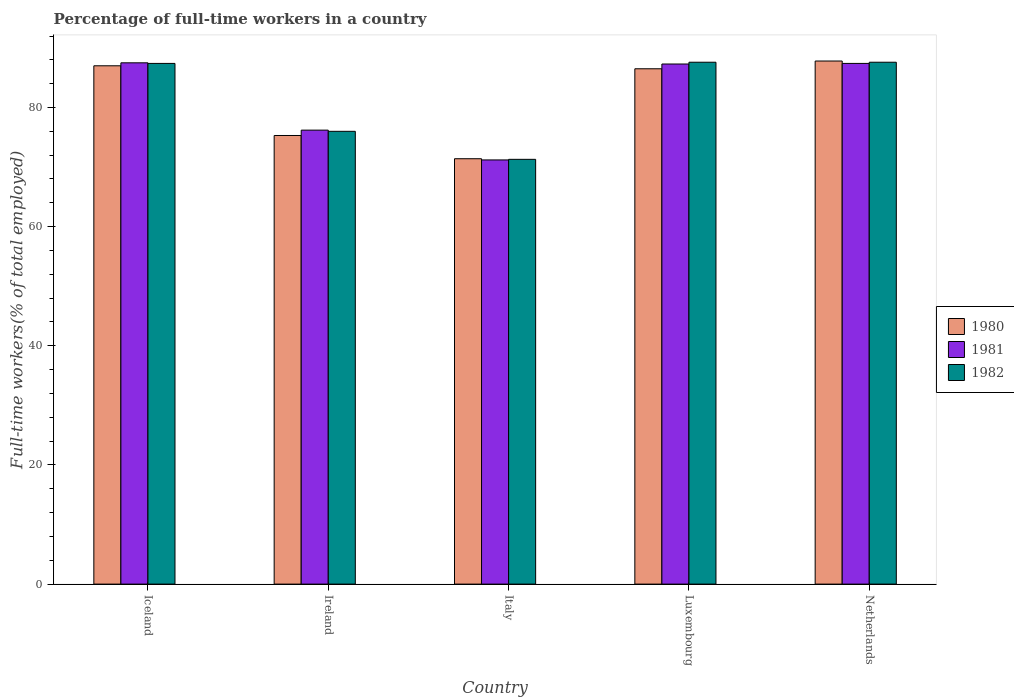Are the number of bars per tick equal to the number of legend labels?
Offer a very short reply. Yes. How many bars are there on the 3rd tick from the right?
Give a very brief answer. 3. What is the label of the 4th group of bars from the left?
Your answer should be compact. Luxembourg. What is the percentage of full-time workers in 1982 in Luxembourg?
Provide a succinct answer. 87.6. Across all countries, what is the maximum percentage of full-time workers in 1981?
Provide a short and direct response. 87.5. Across all countries, what is the minimum percentage of full-time workers in 1981?
Offer a very short reply. 71.2. In which country was the percentage of full-time workers in 1982 maximum?
Give a very brief answer. Luxembourg. What is the total percentage of full-time workers in 1980 in the graph?
Your answer should be compact. 408. What is the difference between the percentage of full-time workers in 1982 in Netherlands and the percentage of full-time workers in 1980 in Ireland?
Your response must be concise. 12.3. What is the average percentage of full-time workers in 1981 per country?
Your answer should be compact. 81.92. What is the difference between the percentage of full-time workers of/in 1980 and percentage of full-time workers of/in 1982 in Italy?
Give a very brief answer. 0.1. What is the ratio of the percentage of full-time workers in 1981 in Ireland to that in Netherlands?
Your answer should be very brief. 0.87. What is the difference between the highest and the second highest percentage of full-time workers in 1981?
Offer a very short reply. -0.1. What is the difference between the highest and the lowest percentage of full-time workers in 1982?
Keep it short and to the point. 16.3. In how many countries, is the percentage of full-time workers in 1981 greater than the average percentage of full-time workers in 1981 taken over all countries?
Keep it short and to the point. 3. What does the 3rd bar from the left in Netherlands represents?
Keep it short and to the point. 1982. What does the 3rd bar from the right in Italy represents?
Offer a very short reply. 1980. Is it the case that in every country, the sum of the percentage of full-time workers in 1981 and percentage of full-time workers in 1980 is greater than the percentage of full-time workers in 1982?
Ensure brevity in your answer.  Yes. What is the difference between two consecutive major ticks on the Y-axis?
Offer a terse response. 20. Are the values on the major ticks of Y-axis written in scientific E-notation?
Make the answer very short. No. Does the graph contain any zero values?
Make the answer very short. No. Does the graph contain grids?
Your answer should be compact. No. Where does the legend appear in the graph?
Offer a terse response. Center right. How are the legend labels stacked?
Your answer should be very brief. Vertical. What is the title of the graph?
Keep it short and to the point. Percentage of full-time workers in a country. Does "2011" appear as one of the legend labels in the graph?
Provide a short and direct response. No. What is the label or title of the Y-axis?
Offer a terse response. Full-time workers(% of total employed). What is the Full-time workers(% of total employed) of 1980 in Iceland?
Provide a short and direct response. 87. What is the Full-time workers(% of total employed) of 1981 in Iceland?
Provide a succinct answer. 87.5. What is the Full-time workers(% of total employed) in 1982 in Iceland?
Offer a terse response. 87.4. What is the Full-time workers(% of total employed) of 1980 in Ireland?
Provide a short and direct response. 75.3. What is the Full-time workers(% of total employed) of 1981 in Ireland?
Provide a succinct answer. 76.2. What is the Full-time workers(% of total employed) in 1980 in Italy?
Offer a terse response. 71.4. What is the Full-time workers(% of total employed) in 1981 in Italy?
Keep it short and to the point. 71.2. What is the Full-time workers(% of total employed) in 1982 in Italy?
Offer a very short reply. 71.3. What is the Full-time workers(% of total employed) in 1980 in Luxembourg?
Your answer should be very brief. 86.5. What is the Full-time workers(% of total employed) of 1981 in Luxembourg?
Offer a terse response. 87.3. What is the Full-time workers(% of total employed) in 1982 in Luxembourg?
Provide a succinct answer. 87.6. What is the Full-time workers(% of total employed) in 1980 in Netherlands?
Offer a terse response. 87.8. What is the Full-time workers(% of total employed) in 1981 in Netherlands?
Offer a terse response. 87.4. What is the Full-time workers(% of total employed) in 1982 in Netherlands?
Provide a short and direct response. 87.6. Across all countries, what is the maximum Full-time workers(% of total employed) in 1980?
Give a very brief answer. 87.8. Across all countries, what is the maximum Full-time workers(% of total employed) of 1981?
Offer a terse response. 87.5. Across all countries, what is the maximum Full-time workers(% of total employed) in 1982?
Provide a short and direct response. 87.6. Across all countries, what is the minimum Full-time workers(% of total employed) of 1980?
Your answer should be compact. 71.4. Across all countries, what is the minimum Full-time workers(% of total employed) in 1981?
Your answer should be compact. 71.2. Across all countries, what is the minimum Full-time workers(% of total employed) of 1982?
Provide a succinct answer. 71.3. What is the total Full-time workers(% of total employed) of 1980 in the graph?
Your answer should be compact. 408. What is the total Full-time workers(% of total employed) in 1981 in the graph?
Provide a short and direct response. 409.6. What is the total Full-time workers(% of total employed) of 1982 in the graph?
Provide a succinct answer. 409.9. What is the difference between the Full-time workers(% of total employed) in 1982 in Iceland and that in Ireland?
Your answer should be compact. 11.4. What is the difference between the Full-time workers(% of total employed) in 1981 in Iceland and that in Italy?
Provide a succinct answer. 16.3. What is the difference between the Full-time workers(% of total employed) of 1980 in Iceland and that in Luxembourg?
Your answer should be very brief. 0.5. What is the difference between the Full-time workers(% of total employed) of 1981 in Iceland and that in Luxembourg?
Provide a succinct answer. 0.2. What is the difference between the Full-time workers(% of total employed) in 1982 in Iceland and that in Netherlands?
Make the answer very short. -0.2. What is the difference between the Full-time workers(% of total employed) in 1980 in Ireland and that in Italy?
Your answer should be compact. 3.9. What is the difference between the Full-time workers(% of total employed) of 1981 in Ireland and that in Italy?
Ensure brevity in your answer.  5. What is the difference between the Full-time workers(% of total employed) in 1982 in Ireland and that in Italy?
Make the answer very short. 4.7. What is the difference between the Full-time workers(% of total employed) of 1980 in Ireland and that in Netherlands?
Keep it short and to the point. -12.5. What is the difference between the Full-time workers(% of total employed) of 1982 in Ireland and that in Netherlands?
Your answer should be compact. -11.6. What is the difference between the Full-time workers(% of total employed) in 1980 in Italy and that in Luxembourg?
Offer a very short reply. -15.1. What is the difference between the Full-time workers(% of total employed) of 1981 in Italy and that in Luxembourg?
Offer a very short reply. -16.1. What is the difference between the Full-time workers(% of total employed) of 1982 in Italy and that in Luxembourg?
Ensure brevity in your answer.  -16.3. What is the difference between the Full-time workers(% of total employed) of 1980 in Italy and that in Netherlands?
Provide a short and direct response. -16.4. What is the difference between the Full-time workers(% of total employed) in 1981 in Italy and that in Netherlands?
Offer a very short reply. -16.2. What is the difference between the Full-time workers(% of total employed) of 1982 in Italy and that in Netherlands?
Your response must be concise. -16.3. What is the difference between the Full-time workers(% of total employed) in 1981 in Luxembourg and that in Netherlands?
Keep it short and to the point. -0.1. What is the difference between the Full-time workers(% of total employed) of 1982 in Luxembourg and that in Netherlands?
Give a very brief answer. 0. What is the difference between the Full-time workers(% of total employed) in 1980 in Iceland and the Full-time workers(% of total employed) in 1981 in Ireland?
Your answer should be very brief. 10.8. What is the difference between the Full-time workers(% of total employed) of 1981 in Iceland and the Full-time workers(% of total employed) of 1982 in Italy?
Ensure brevity in your answer.  16.2. What is the difference between the Full-time workers(% of total employed) in 1980 in Iceland and the Full-time workers(% of total employed) in 1982 in Luxembourg?
Keep it short and to the point. -0.6. What is the difference between the Full-time workers(% of total employed) in 1981 in Iceland and the Full-time workers(% of total employed) in 1982 in Luxembourg?
Your response must be concise. -0.1. What is the difference between the Full-time workers(% of total employed) in 1980 in Iceland and the Full-time workers(% of total employed) in 1981 in Netherlands?
Offer a terse response. -0.4. What is the difference between the Full-time workers(% of total employed) in 1980 in Iceland and the Full-time workers(% of total employed) in 1982 in Netherlands?
Ensure brevity in your answer.  -0.6. What is the difference between the Full-time workers(% of total employed) in 1980 in Ireland and the Full-time workers(% of total employed) in 1981 in Italy?
Provide a short and direct response. 4.1. What is the difference between the Full-time workers(% of total employed) of 1980 in Ireland and the Full-time workers(% of total employed) of 1982 in Italy?
Give a very brief answer. 4. What is the difference between the Full-time workers(% of total employed) in 1981 in Ireland and the Full-time workers(% of total employed) in 1982 in Luxembourg?
Ensure brevity in your answer.  -11.4. What is the difference between the Full-time workers(% of total employed) of 1980 in Ireland and the Full-time workers(% of total employed) of 1982 in Netherlands?
Your response must be concise. -12.3. What is the difference between the Full-time workers(% of total employed) in 1980 in Italy and the Full-time workers(% of total employed) in 1981 in Luxembourg?
Your response must be concise. -15.9. What is the difference between the Full-time workers(% of total employed) of 1980 in Italy and the Full-time workers(% of total employed) of 1982 in Luxembourg?
Ensure brevity in your answer.  -16.2. What is the difference between the Full-time workers(% of total employed) of 1981 in Italy and the Full-time workers(% of total employed) of 1982 in Luxembourg?
Ensure brevity in your answer.  -16.4. What is the difference between the Full-time workers(% of total employed) in 1980 in Italy and the Full-time workers(% of total employed) in 1982 in Netherlands?
Your answer should be compact. -16.2. What is the difference between the Full-time workers(% of total employed) of 1981 in Italy and the Full-time workers(% of total employed) of 1982 in Netherlands?
Your response must be concise. -16.4. What is the difference between the Full-time workers(% of total employed) of 1980 in Luxembourg and the Full-time workers(% of total employed) of 1981 in Netherlands?
Your answer should be compact. -0.9. What is the average Full-time workers(% of total employed) in 1980 per country?
Your answer should be compact. 81.6. What is the average Full-time workers(% of total employed) in 1981 per country?
Ensure brevity in your answer.  81.92. What is the average Full-time workers(% of total employed) of 1982 per country?
Ensure brevity in your answer.  81.98. What is the difference between the Full-time workers(% of total employed) of 1980 and Full-time workers(% of total employed) of 1981 in Iceland?
Give a very brief answer. -0.5. What is the difference between the Full-time workers(% of total employed) of 1981 and Full-time workers(% of total employed) of 1982 in Iceland?
Make the answer very short. 0.1. What is the difference between the Full-time workers(% of total employed) in 1980 and Full-time workers(% of total employed) in 1982 in Ireland?
Provide a succinct answer. -0.7. What is the difference between the Full-time workers(% of total employed) of 1980 and Full-time workers(% of total employed) of 1981 in Italy?
Give a very brief answer. 0.2. What is the difference between the Full-time workers(% of total employed) of 1981 and Full-time workers(% of total employed) of 1982 in Italy?
Your answer should be compact. -0.1. What is the difference between the Full-time workers(% of total employed) in 1980 and Full-time workers(% of total employed) in 1982 in Netherlands?
Keep it short and to the point. 0.2. What is the difference between the Full-time workers(% of total employed) of 1981 and Full-time workers(% of total employed) of 1982 in Netherlands?
Your answer should be very brief. -0.2. What is the ratio of the Full-time workers(% of total employed) in 1980 in Iceland to that in Ireland?
Give a very brief answer. 1.16. What is the ratio of the Full-time workers(% of total employed) of 1981 in Iceland to that in Ireland?
Offer a very short reply. 1.15. What is the ratio of the Full-time workers(% of total employed) in 1982 in Iceland to that in Ireland?
Ensure brevity in your answer.  1.15. What is the ratio of the Full-time workers(% of total employed) in 1980 in Iceland to that in Italy?
Keep it short and to the point. 1.22. What is the ratio of the Full-time workers(% of total employed) in 1981 in Iceland to that in Italy?
Offer a terse response. 1.23. What is the ratio of the Full-time workers(% of total employed) of 1982 in Iceland to that in Italy?
Ensure brevity in your answer.  1.23. What is the ratio of the Full-time workers(% of total employed) of 1982 in Iceland to that in Luxembourg?
Give a very brief answer. 1. What is the ratio of the Full-time workers(% of total employed) of 1980 in Iceland to that in Netherlands?
Offer a very short reply. 0.99. What is the ratio of the Full-time workers(% of total employed) in 1981 in Iceland to that in Netherlands?
Make the answer very short. 1. What is the ratio of the Full-time workers(% of total employed) of 1982 in Iceland to that in Netherlands?
Provide a short and direct response. 1. What is the ratio of the Full-time workers(% of total employed) in 1980 in Ireland to that in Italy?
Keep it short and to the point. 1.05. What is the ratio of the Full-time workers(% of total employed) of 1981 in Ireland to that in Italy?
Provide a succinct answer. 1.07. What is the ratio of the Full-time workers(% of total employed) of 1982 in Ireland to that in Italy?
Keep it short and to the point. 1.07. What is the ratio of the Full-time workers(% of total employed) in 1980 in Ireland to that in Luxembourg?
Your response must be concise. 0.87. What is the ratio of the Full-time workers(% of total employed) in 1981 in Ireland to that in Luxembourg?
Offer a terse response. 0.87. What is the ratio of the Full-time workers(% of total employed) of 1982 in Ireland to that in Luxembourg?
Provide a succinct answer. 0.87. What is the ratio of the Full-time workers(% of total employed) of 1980 in Ireland to that in Netherlands?
Offer a terse response. 0.86. What is the ratio of the Full-time workers(% of total employed) of 1981 in Ireland to that in Netherlands?
Make the answer very short. 0.87. What is the ratio of the Full-time workers(% of total employed) of 1982 in Ireland to that in Netherlands?
Your answer should be compact. 0.87. What is the ratio of the Full-time workers(% of total employed) of 1980 in Italy to that in Luxembourg?
Keep it short and to the point. 0.83. What is the ratio of the Full-time workers(% of total employed) of 1981 in Italy to that in Luxembourg?
Offer a very short reply. 0.82. What is the ratio of the Full-time workers(% of total employed) of 1982 in Italy to that in Luxembourg?
Keep it short and to the point. 0.81. What is the ratio of the Full-time workers(% of total employed) of 1980 in Italy to that in Netherlands?
Your answer should be very brief. 0.81. What is the ratio of the Full-time workers(% of total employed) in 1981 in Italy to that in Netherlands?
Offer a very short reply. 0.81. What is the ratio of the Full-time workers(% of total employed) in 1982 in Italy to that in Netherlands?
Provide a succinct answer. 0.81. What is the ratio of the Full-time workers(% of total employed) in 1980 in Luxembourg to that in Netherlands?
Your answer should be very brief. 0.99. What is the ratio of the Full-time workers(% of total employed) of 1982 in Luxembourg to that in Netherlands?
Give a very brief answer. 1. What is the difference between the highest and the second highest Full-time workers(% of total employed) of 1980?
Give a very brief answer. 0.8. What is the difference between the highest and the second highest Full-time workers(% of total employed) of 1981?
Ensure brevity in your answer.  0.1. What is the difference between the highest and the second highest Full-time workers(% of total employed) in 1982?
Keep it short and to the point. 0. What is the difference between the highest and the lowest Full-time workers(% of total employed) in 1980?
Your answer should be very brief. 16.4. What is the difference between the highest and the lowest Full-time workers(% of total employed) in 1981?
Offer a very short reply. 16.3. 